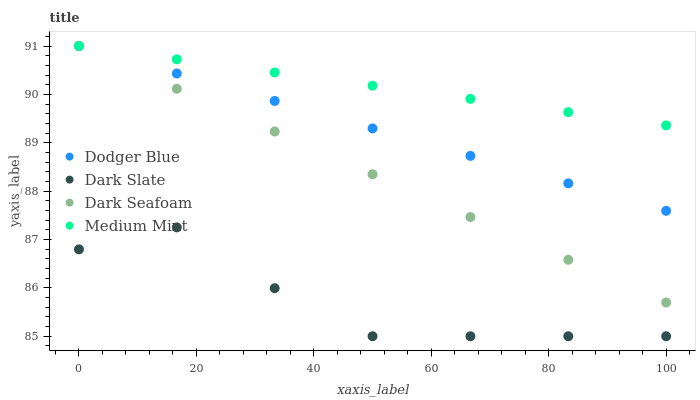Does Dark Slate have the minimum area under the curve?
Answer yes or no. Yes. Does Medium Mint have the maximum area under the curve?
Answer yes or no. Yes. Does Dark Seafoam have the minimum area under the curve?
Answer yes or no. No. Does Dark Seafoam have the maximum area under the curve?
Answer yes or no. No. Is Medium Mint the smoothest?
Answer yes or no. Yes. Is Dark Slate the roughest?
Answer yes or no. Yes. Is Dark Seafoam the smoothest?
Answer yes or no. No. Is Dark Seafoam the roughest?
Answer yes or no. No. Does Dark Slate have the lowest value?
Answer yes or no. Yes. Does Dark Seafoam have the lowest value?
Answer yes or no. No. Does Dodger Blue have the highest value?
Answer yes or no. Yes. Does Dark Slate have the highest value?
Answer yes or no. No. Is Dark Slate less than Dodger Blue?
Answer yes or no. Yes. Is Medium Mint greater than Dark Slate?
Answer yes or no. Yes. Does Dodger Blue intersect Medium Mint?
Answer yes or no. Yes. Is Dodger Blue less than Medium Mint?
Answer yes or no. No. Is Dodger Blue greater than Medium Mint?
Answer yes or no. No. Does Dark Slate intersect Dodger Blue?
Answer yes or no. No. 